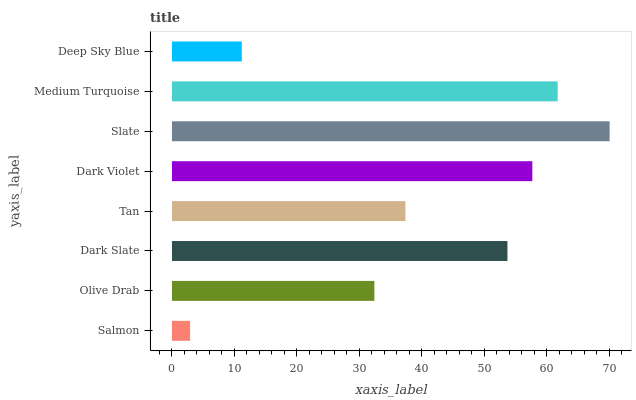Is Salmon the minimum?
Answer yes or no. Yes. Is Slate the maximum?
Answer yes or no. Yes. Is Olive Drab the minimum?
Answer yes or no. No. Is Olive Drab the maximum?
Answer yes or no. No. Is Olive Drab greater than Salmon?
Answer yes or no. Yes. Is Salmon less than Olive Drab?
Answer yes or no. Yes. Is Salmon greater than Olive Drab?
Answer yes or no. No. Is Olive Drab less than Salmon?
Answer yes or no. No. Is Dark Slate the high median?
Answer yes or no. Yes. Is Tan the low median?
Answer yes or no. Yes. Is Dark Violet the high median?
Answer yes or no. No. Is Slate the low median?
Answer yes or no. No. 